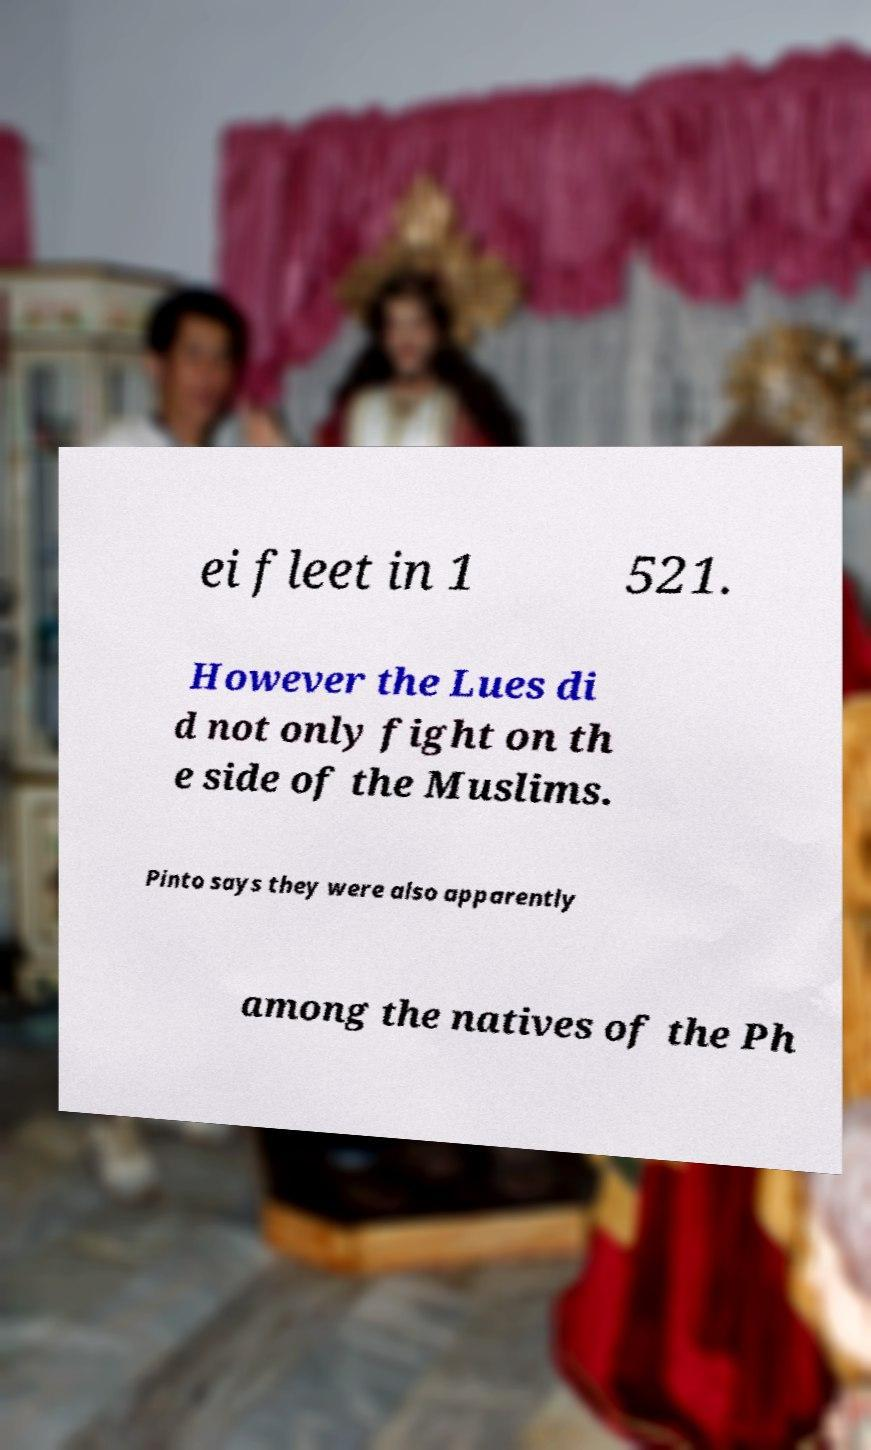Can you accurately transcribe the text from the provided image for me? ei fleet in 1 521. However the Lues di d not only fight on th e side of the Muslims. Pinto says they were also apparently among the natives of the Ph 